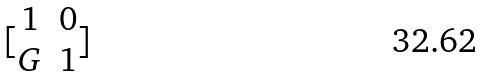Convert formula to latex. <formula><loc_0><loc_0><loc_500><loc_500>[ \begin{matrix} 1 & 0 \\ G & 1 \end{matrix} ]</formula> 